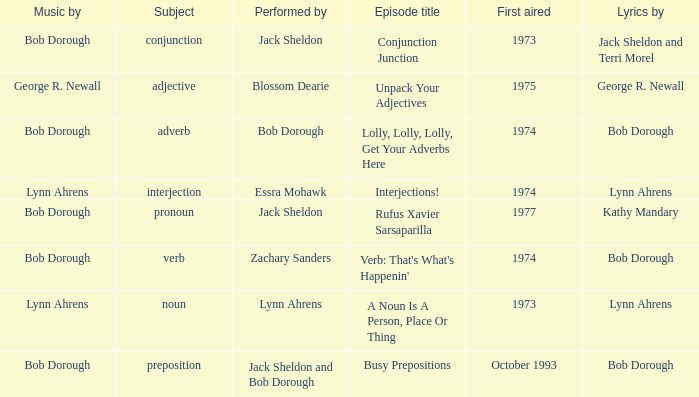When conjunction junction is the episode title and the music is by bob dorough who is the performer? Jack Sheldon. 